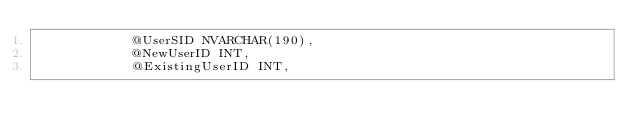Convert code to text. <code><loc_0><loc_0><loc_500><loc_500><_SQL_>			@UserSID NVARCHAR(190),
			@NewUserID INT,
			@ExistingUserID INT,</code> 